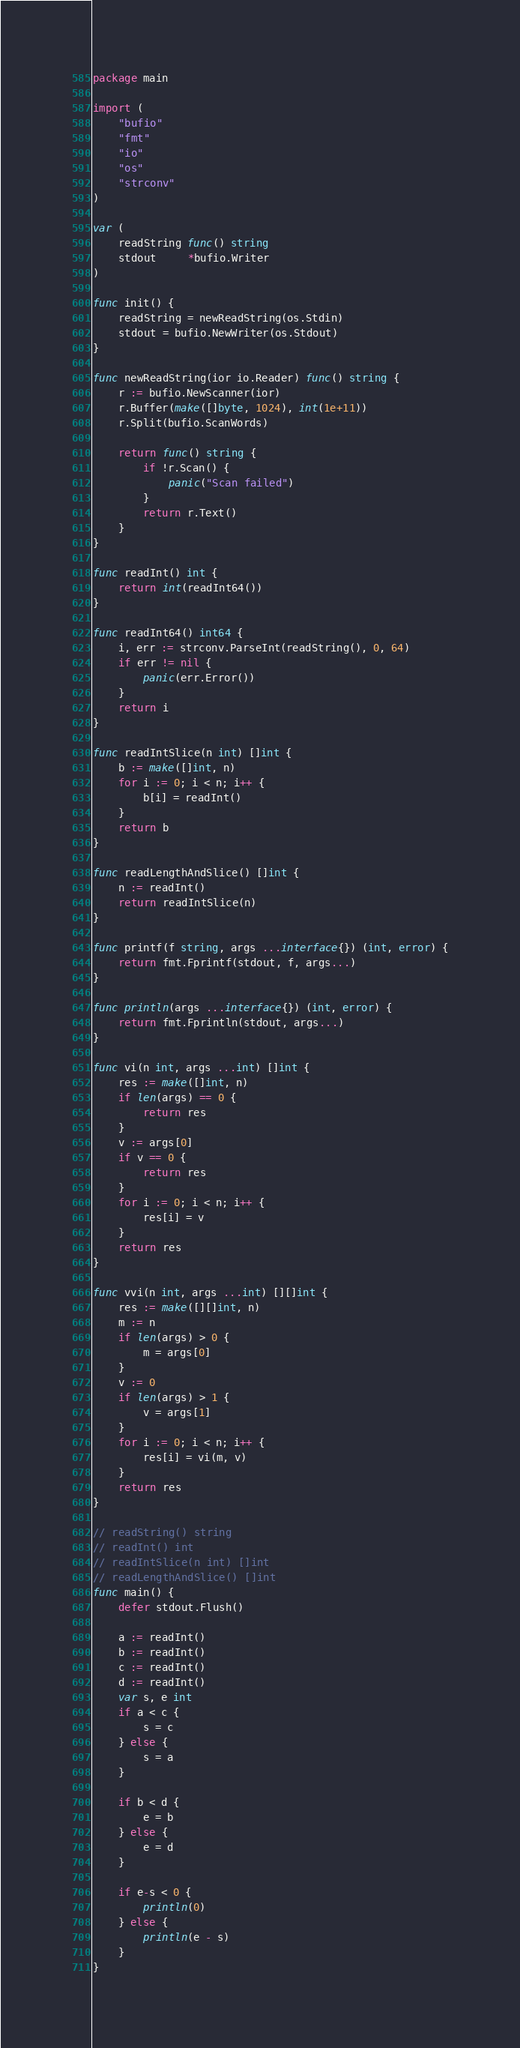<code> <loc_0><loc_0><loc_500><loc_500><_Go_>package main

import (
	"bufio"
	"fmt"
	"io"
	"os"
	"strconv"
)

var (
	readString func() string
	stdout     *bufio.Writer
)

func init() {
	readString = newReadString(os.Stdin)
	stdout = bufio.NewWriter(os.Stdout)
}

func newReadString(ior io.Reader) func() string {
	r := bufio.NewScanner(ior)
	r.Buffer(make([]byte, 1024), int(1e+11))
	r.Split(bufio.ScanWords)

	return func() string {
		if !r.Scan() {
			panic("Scan failed")
		}
		return r.Text()
	}
}

func readInt() int {
	return int(readInt64())
}

func readInt64() int64 {
	i, err := strconv.ParseInt(readString(), 0, 64)
	if err != nil {
		panic(err.Error())
	}
	return i
}

func readIntSlice(n int) []int {
	b := make([]int, n)
	for i := 0; i < n; i++ {
		b[i] = readInt()
	}
	return b
}

func readLengthAndSlice() []int {
	n := readInt()
	return readIntSlice(n)
}

func printf(f string, args ...interface{}) (int, error) {
	return fmt.Fprintf(stdout, f, args...)
}

func println(args ...interface{}) (int, error) {
	return fmt.Fprintln(stdout, args...)
}

func vi(n int, args ...int) []int {
	res := make([]int, n)
	if len(args) == 0 {
		return res
	}
	v := args[0]
	if v == 0 {
		return res
	}
	for i := 0; i < n; i++ {
		res[i] = v
	}
	return res
}

func vvi(n int, args ...int) [][]int {
	res := make([][]int, n)
	m := n
	if len(args) > 0 {
		m = args[0]
	}
	v := 0
	if len(args) > 1 {
		v = args[1]
	}
	for i := 0; i < n; i++ {
		res[i] = vi(m, v)
	}
	return res
}

// readString() string
// readInt() int
// readIntSlice(n int) []int
// readLengthAndSlice() []int
func main() {
	defer stdout.Flush()

	a := readInt()
	b := readInt()
	c := readInt()
	d := readInt()
	var s, e int
	if a < c {
		s = c
	} else {
		s = a
	}

	if b < d {
		e = b
	} else {
		e = d
	}

	if e-s < 0 {
		println(0)
	} else {
		println(e - s)
	}
}
</code> 